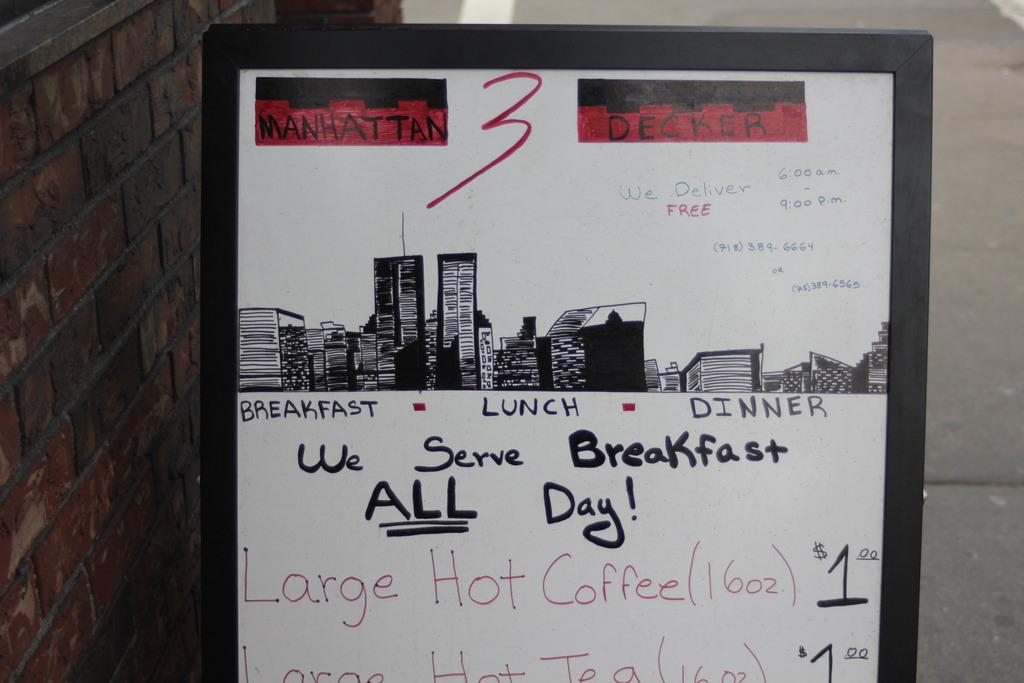<image>
Summarize the visual content of the image. A whiteboard advertises breakfast, lunch, and dinner, under a city skyline drawing. 